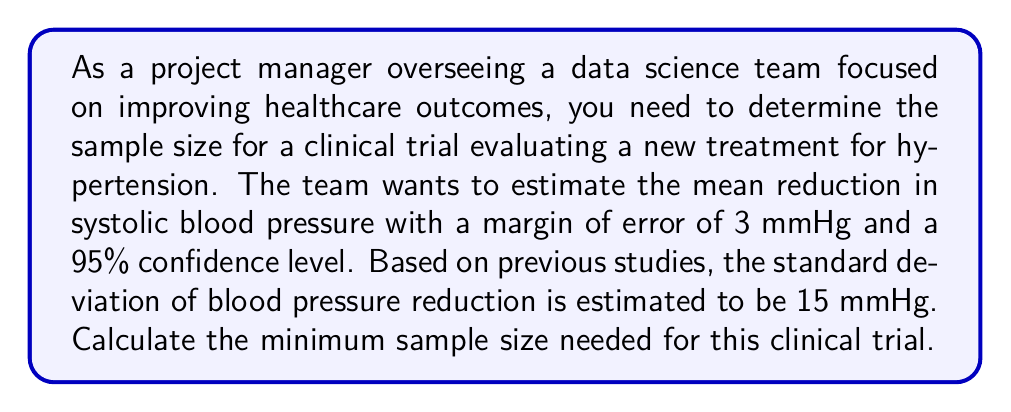Solve this math problem. To calculate the sample size for this clinical trial, we'll use the formula for sample size determination for estimating a population mean:

$$n = \left(\frac{z_{\alpha/2} \cdot \sigma}{E}\right)^2$$

Where:
$n$ = sample size
$z_{\alpha/2}$ = z-score for the desired confidence level
$\sigma$ = population standard deviation
$E$ = margin of error

Step 1: Identify the known values
- Confidence level = 95% (z-score = 1.96)
- Margin of error (E) = 3 mmHg
- Standard deviation (σ) = 15 mmHg

Step 2: Plug the values into the formula
$$n = \left(\frac{1.96 \cdot 15}{3}\right)^2$$

Step 3: Calculate the result
$$n = (9.8)^2 = 96.04$$

Step 4: Round up to the nearest whole number
Since we can't have a fractional number of participants, we round up to 97.

Therefore, the minimum sample size needed for this clinical trial is 97 participants.
Answer: 97 participants 